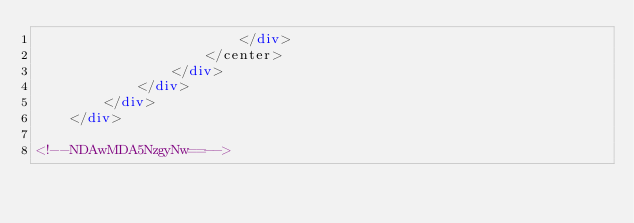Convert code to text. <code><loc_0><loc_0><loc_500><loc_500><_HTML_>                        </div>
                    </center>
                </div>
            </div>
        </div>
    </div>

<!--NDAwMDA5NzgyNw==--></code> 